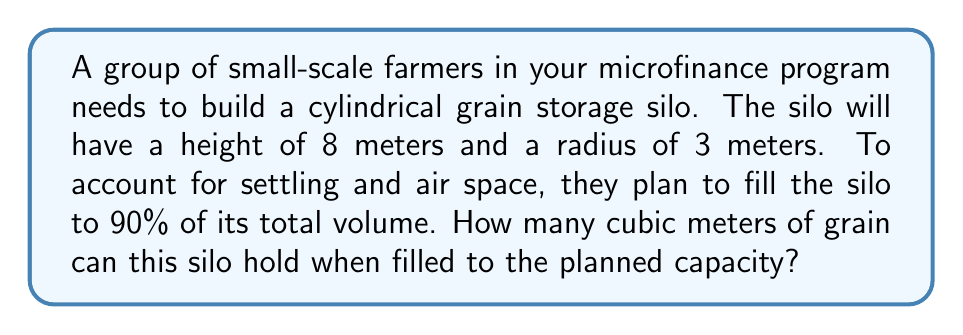Give your solution to this math problem. To solve this problem, we'll follow these steps:

1. Calculate the total volume of the cylindrical silo
2. Find 90% of the total volume to account for settling and air space

Step 1: Calculate the total volume of the cylindrical silo

The volume of a cylinder is given by the formula:

$$V = \pi r^2 h$$

Where:
$V$ = volume
$r$ = radius
$h$ = height

Given:
$r = 3$ meters
$h = 8$ meters

Let's substitute these values into the formula:

$$V = \pi (3\text{ m})^2 (8\text{ m})$$
$$V = \pi (9\text{ m}^2) (8\text{ m})$$
$$V = 72\pi\text{ m}^3$$

Step 2: Find 90% of the total volume

To calculate 90% of the total volume, we multiply the result from Step 1 by 0.90:

$$\text{Usable Volume} = 72\pi\text{ m}^3 \times 0.90$$
$$\text{Usable Volume} = 64.8\pi\text{ m}^3$$

Now, let's calculate the final value:

$$\text{Usable Volume} \approx 203.58\text{ m}^3$$

Therefore, the silo can hold approximately 203.58 cubic meters of grain when filled to 90% capacity.
Answer: $203.58\text{ m}^3$ (rounded to two decimal places) 